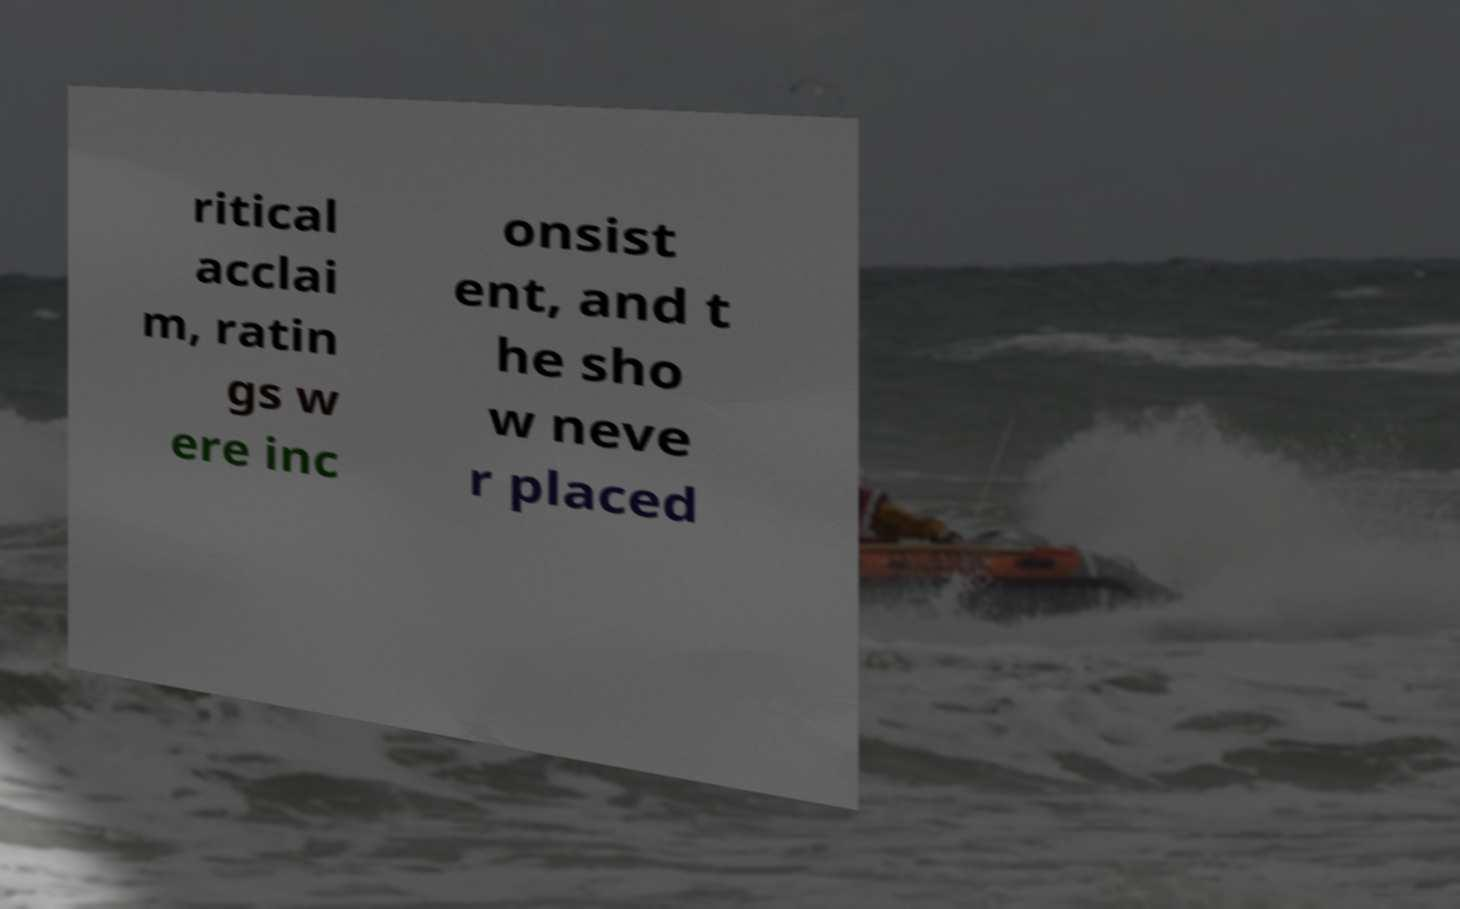Could you extract and type out the text from this image? ritical acclai m, ratin gs w ere inc onsist ent, and t he sho w neve r placed 